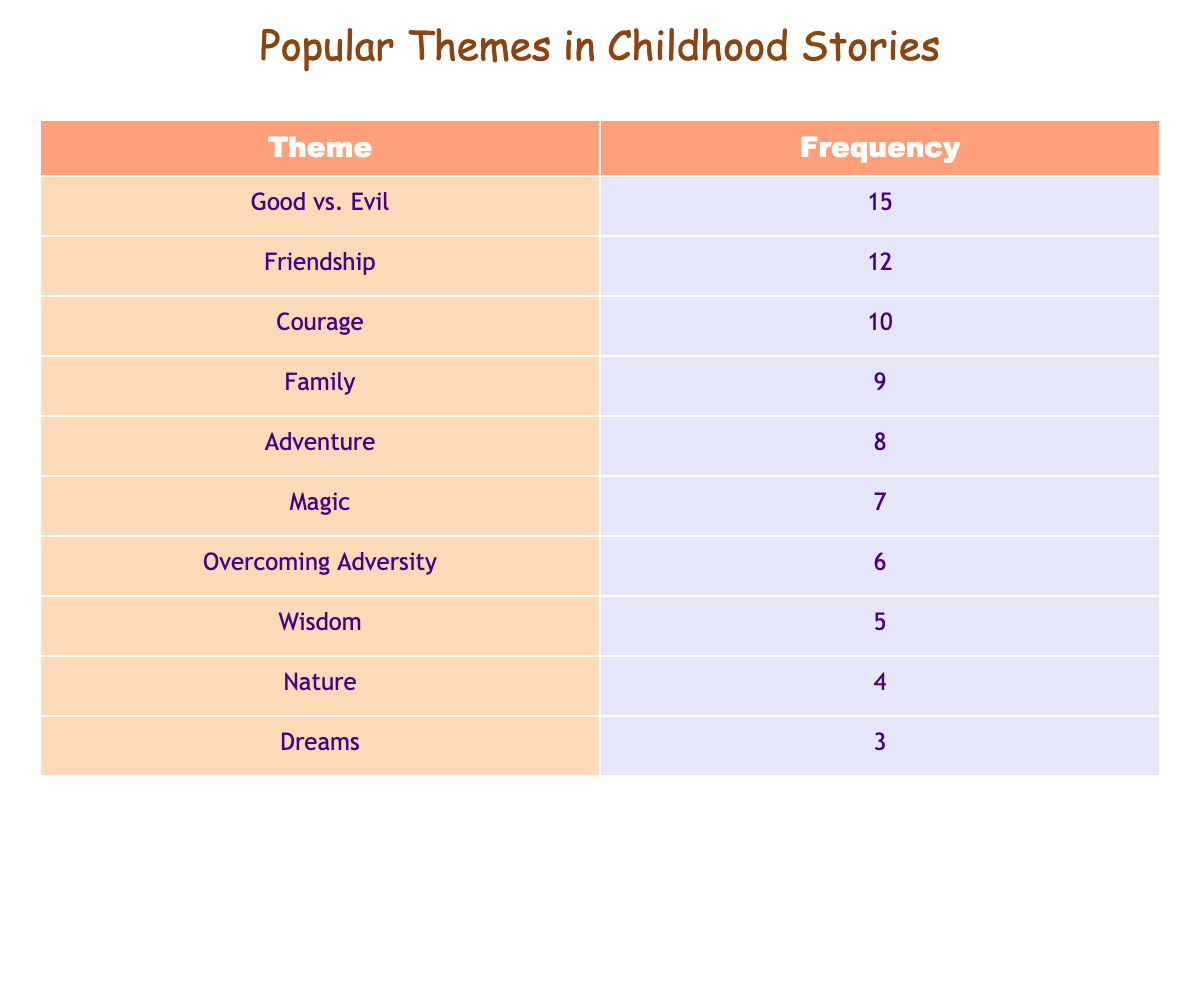What is the most popular theme in childhood stories? The table shows that "Good vs. Evil" has the highest frequency with 15 occurrences, making it the most popular theme.
Answer: Good vs. Evil How many stories focus on Friendship? According to the table, the frequency for "Friendship" is listed as 12.
Answer: 12 What is the difference in frequency between Adventure and Magic themes? "Adventure" has a frequency of 8, while "Magic" has a frequency of 7. The difference is calculated as 8 - 7 = 1.
Answer: 1 Is Overcoming Adversity a more common theme than Nature in childhood stories? "Overcoming Adversity" has a frequency of 6, and "Nature" has a frequency of 4. Since 6 is greater than 4, the answer is yes.
Answer: Yes What is the total frequency of themes related to family and friendship combined? The frequency for "Family" is 9, and for "Friendship," it is 12. Adding them gives a total of 9 + 12 = 21.
Answer: 21 What is the average frequency of all themes in the table? To find the average, sum all the frequencies: 15 + 12 + 10 + 9 + 8 + 7 + 6 + 5 + 4 + 3 = 79. There are 10 themes in total, so the average is 79 / 10 = 7.9.
Answer: 7.9 Which themes have a frequency of 6 or more? The themes that have a frequency of 6 or more are "Good vs. Evil" (15), "Friendship" (12), "Courage" (10), "Family" (9), "Adventure" (8), "Magic" (7), and "Overcoming Adversity" (6).
Answer: Good vs. Evil, Friendship, Courage, Family, Adventure, Magic, Overcoming Adversity Is there a theme with the frequency of exactly 5? The table shows that "Wisdom" has a frequency of 5, thus confirming that there is a theme with that frequency.
Answer: Yes What is the least popular theme in childhood stories and its frequency? The theme with the least frequency is "Dreams," which has a frequency of 3, making it the least popular theme in the table.
Answer: Dreams, 3 